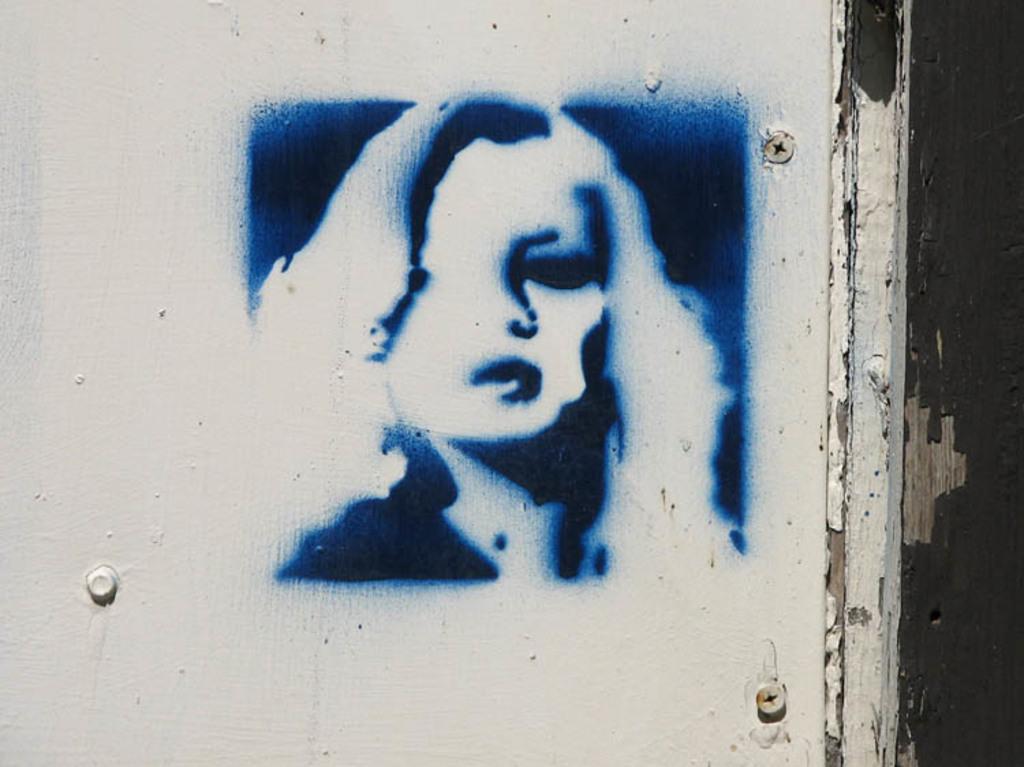Could you give a brief overview of what you see in this image? In this image we can see a wall with a painting of a lady. Also there are screws on the wall. 